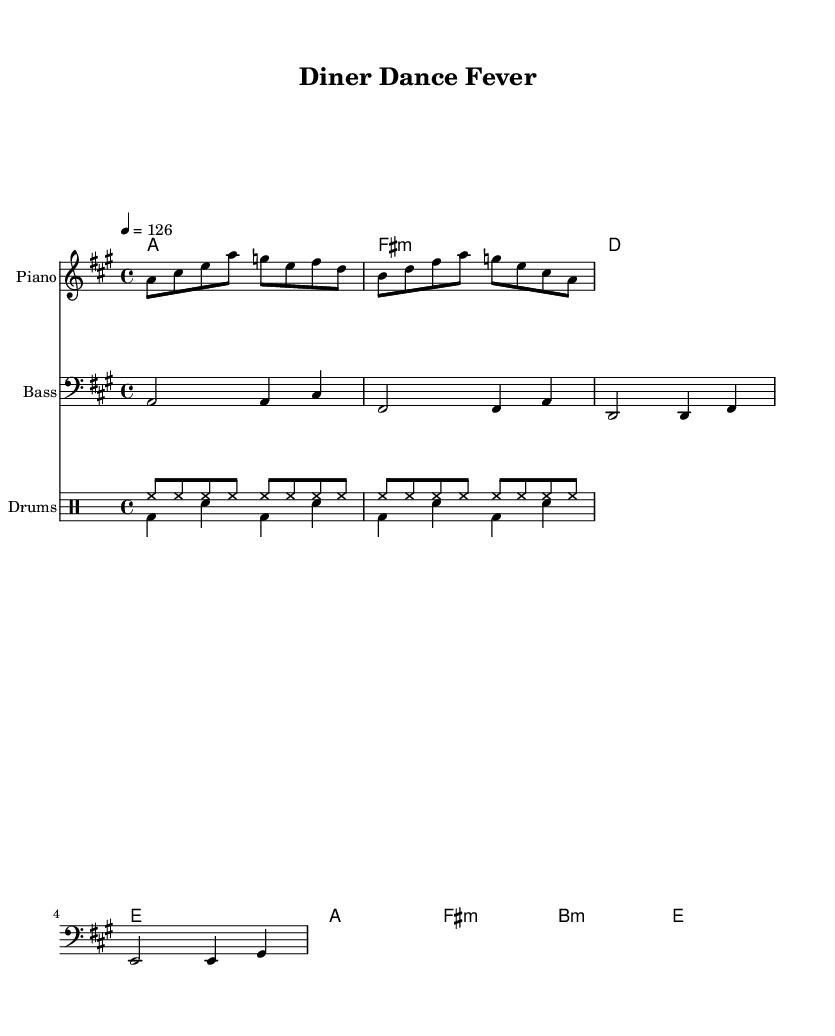What is the key signature of this music? The key signature is A major, which has three sharps: F#, C#, and G#. This can be found at the beginning of the staff.
Answer: A major What is the time signature of this music? The time signature is 4/4, which indicates that there are four beats in each measure and the quarter note gets one beat. This is typically shown at the beginning of the piece.
Answer: 4/4 What is the tempo marking in this piece? The tempo marking is 126 beats per minute, indicated above the staff. This means the music should be played at a moderate speed, creating an upbeat feel appropriate for a dance track.
Answer: 126 How many measures are there in the Electric Piano part? The Electric Piano part contains 8 measures. Each complete phrase can be counted as one measure, and these can be visually identified on the staff.
Answer: 8 What type of percussion pattern is used in this piece? The percussion pattern includes a combination of hi-hat and bass drum sounds, typical in disco music for creating an upbeat feel. The hi-hat plays consistently, while the bass drum adds accents.
Answer: Disco Which chords are used in the chord progression? The chords used are A major, F# minor, D major, and E major, followed by A major, F# minor, B minor, and E major. These chords provide a harmonic foundation appropriate for a disco track.
Answer: A, F# minor, D, E, B minor What instrument plays the bass line? The bass line is played by the bass guitar, which is notated on the bass clef staff and provides a deep, rhythmic foundation for the piece.
Answer: Bass guitar 